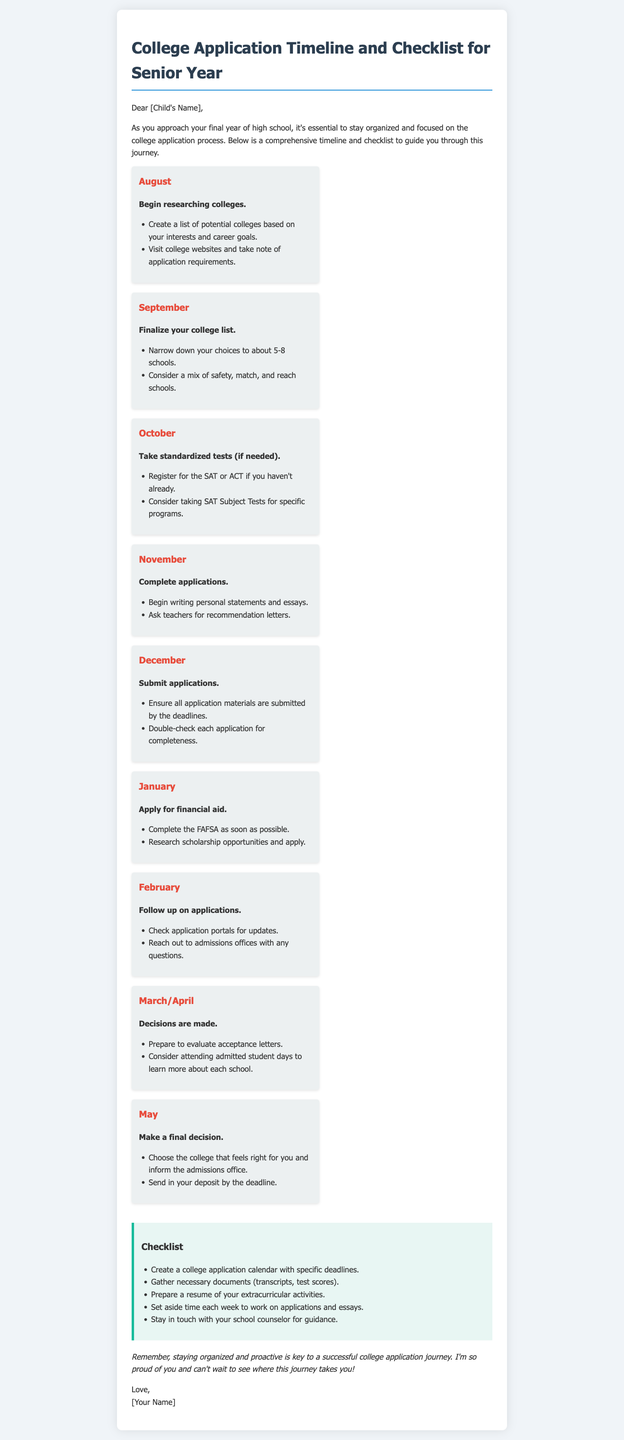What month should you begin researching colleges? The document specifies to begin researching colleges in August.
Answer: August What is a recommended number of schools to finalize your college list? The document suggests narrowing down your choices to about 5-8 schools.
Answer: 5-8 schools What standardized tests may need to be taken in October? The document mentions registering for the SAT or ACT if not already done.
Answer: SAT or ACT When should applications be submitted? The document states that all application materials should be submitted by the deadlines in December.
Answer: December What should you complete as soon as possible in January? The document emphasizes to complete the FAFSA as soon as possible for financial aid.
Answer: FAFSA What action should be taken after receiving admission decisions? The document suggests preparing to evaluate acceptance letters in March/April.
Answer: Evaluate acceptance letters What is one item on the checklist for college applications? The document lists gathering necessary documents (transcripts, test scores) as part of the checklist.
Answer: Gather necessary documents What is the purpose of the college application calendar? The document indicates that the calendar is used to outline specific deadlines for applications.
Answer: Specific deadlines Why is it important to stay in touch with the school counselor? The document advises staying in touch for guidance throughout the application process.
Answer: Guidance 